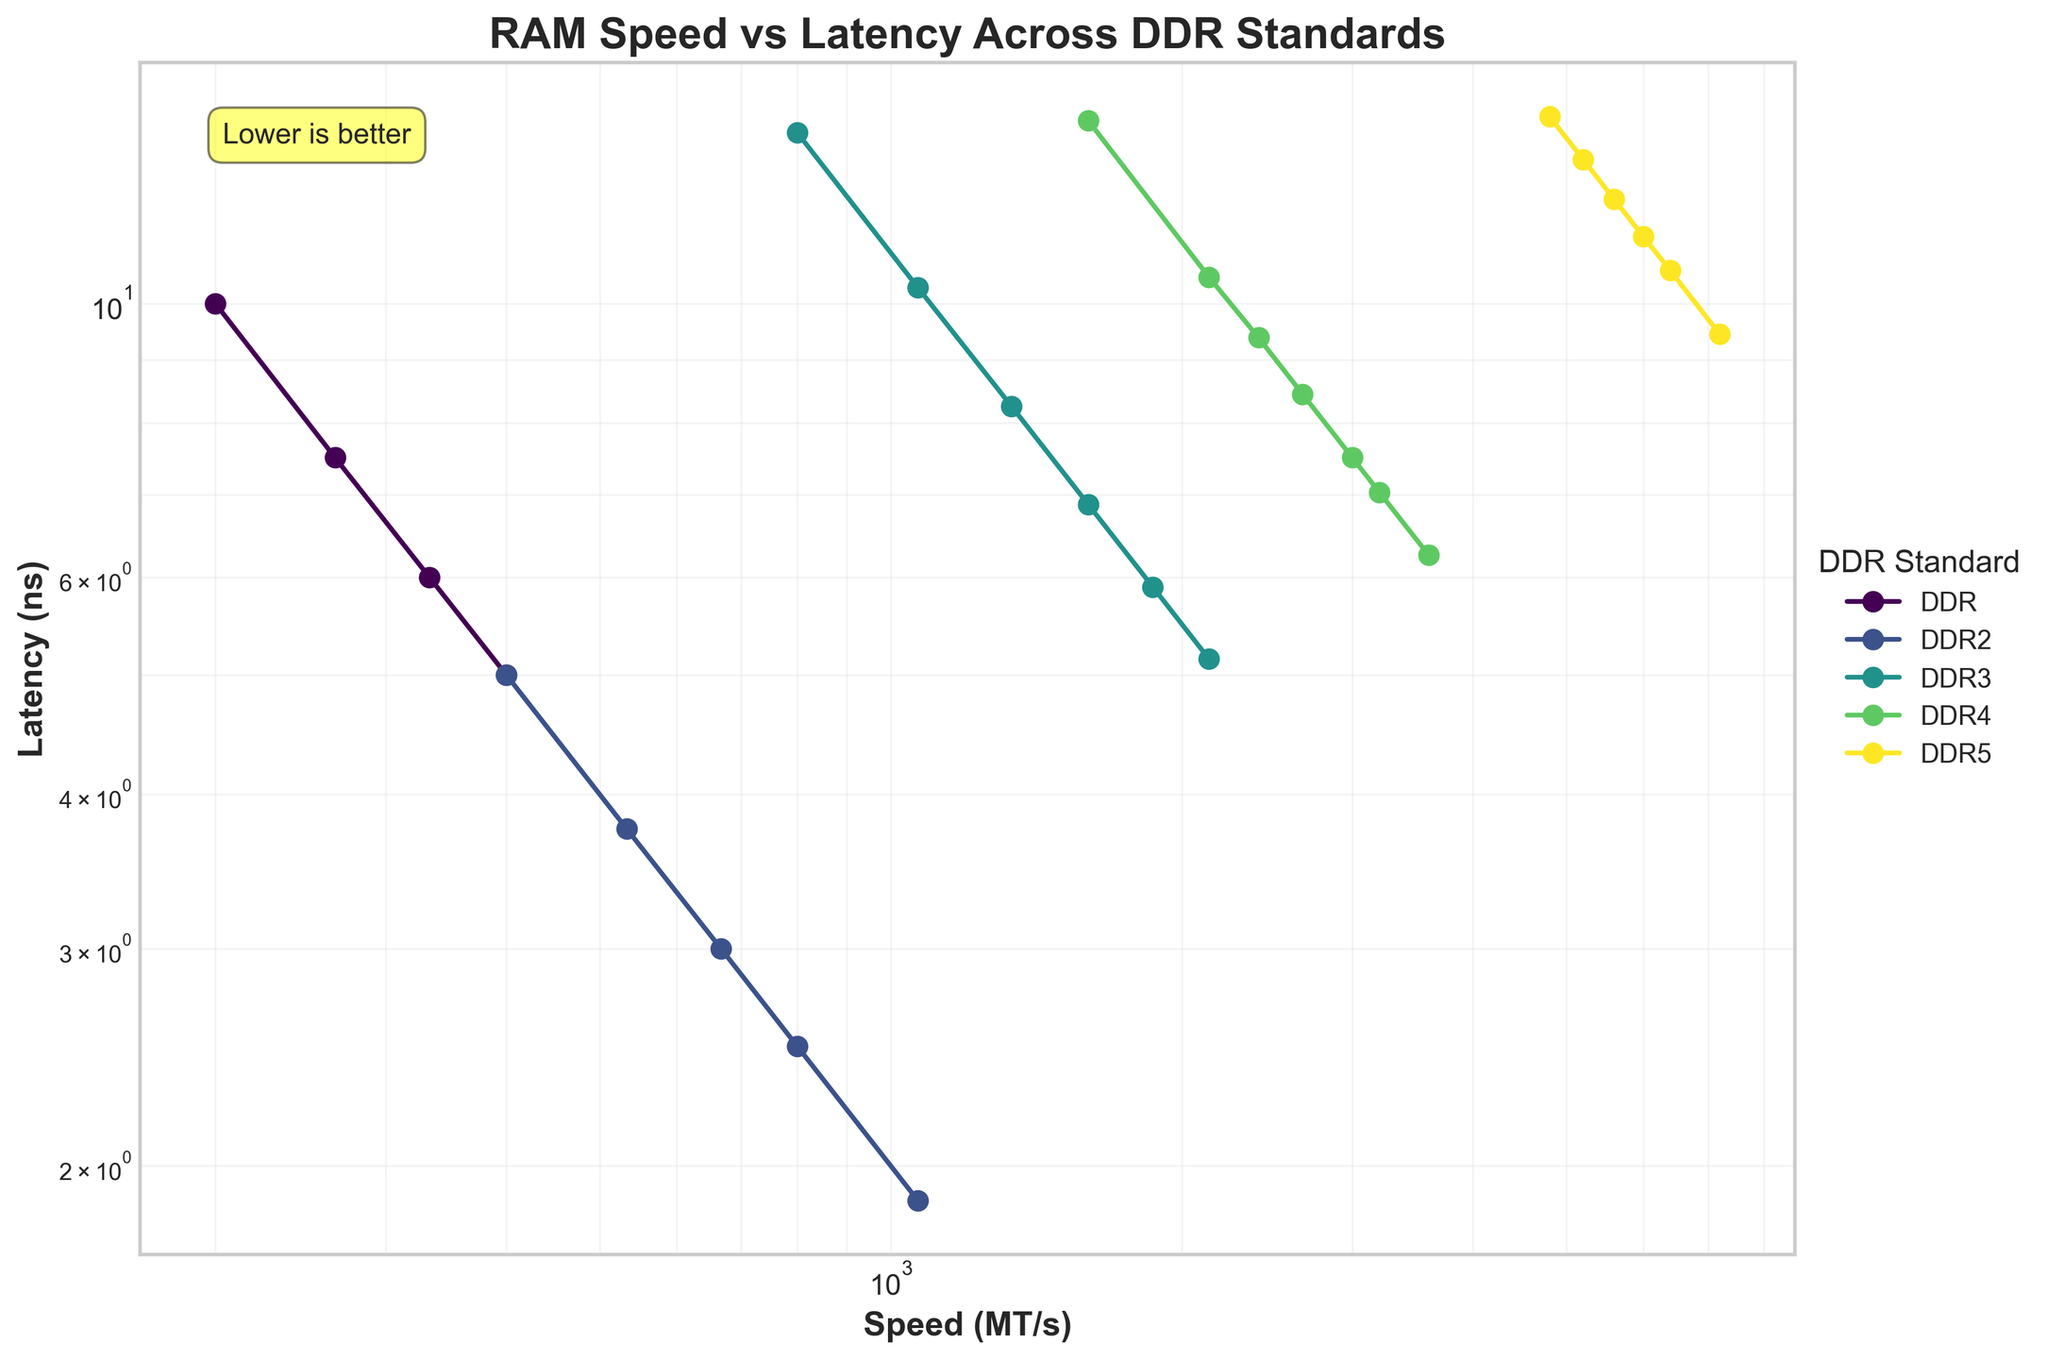What's the DDR standard with the lowest latency for a given speed? To find the DDR standard with the lowest latency for a given speed, look for the lowest point on the y-axis at each specific speed value on the x-axis. For example, at 1600 MT/s, DDR3 has the lowest latency of 6.87 ns.
Answer: DDR3 Which DDR standard has the highest speed with the lowest latency values? To determine which DDR standard has the highest speed and lowest latency, look at the point farthest to the right and lowest on the y-axis in the plot. The DDR5 standard achieves the highest speed of 7200 MT/s with a latency of 9.44 ns.
Answer: DDR5 Compare DDR4 and DDR5 for speed range from 3000 MT/s to 3600 MT/s. Which one has lower latency? For the speed range of 3000 MT/s to 3600 MT/s, find the points within the range for both DDR4 and DDR5, then compare their latencies. DDR4 at 3000 MT/s has 7.5 ns and at 3200 MT/s has 7.03 ns, whereas DDR5 does not have speeds listed precisely within this range. However, DDR4's latencies are generally lower within this specific speed range.
Answer: DDR4 Which DDR standard shows the most apparent decrease in latency as speed increases? To identify which DDR standard shows the most noticeable decrease in latency as speed increases, observe the slopes of the lines. The steepness of the line indicates a significant decrease. DDR2 shows a steep decrease in latency from 5 ns at 400 MT/s to 1.875 ns at 1066 MT/s.
Answer: DDR2 For DDR, what is the difference in latency between 200 MT/s and 400 MT/s? Calculate the difference between the latencies for DDR at 200 MT/s and 400 MT/s. DDR at 200 MT/s has a latency of 10 ns, and at 400 MT/s, it is 5 ns. So, the difference is 10 - 5 = 5 ns.
Answer: 5 ns What is the average latency for DDR4 across all its listed speeds? To find the average latency for DDR4, sum up all the latencies and divide by the number of points. The DDR4 latencies are: 14.06, 10.5, 9.38, 8.44, 7.5, 7.03, 6.25. Their sum is 63.16 ns, and there are 7 points, so average latency is 63.16 / 7 ≈ 9.02 ns.
Answer: 9.02 ns Compare the latencies of DDR3 and DDR4 at the speed of 2133 MT/s. Which one is lower, and by how much? Look at the latencies of both DDR3 and DDR4 at 2133 MT/s. DDR3 at 2133 MT/s has a latency of 5.15 ns, and DDR4 at 2133 MT/s has a latency of 10.5 ns. The difference is 10.5 - 5.15 = 5.35 ns.
Answer: DDR3 by 5.35 ns Which standard exhibits the highest latency, and at what speed? Identify the highest point on the y-axis within the graph. DDR3 at 800 MT/s has the highest latency of 13.75 ns.
Answer: DDR3 at 800 MT/s What trend can be observed for DDR5 latencies as speed increases? Observe the line for DDR5 to detect any trend as speed increases. The plot shows that as speed increases from 4800 MT/s to 7200 MT/s, the latency decreases from 14.17 ns to 9.44 ns, indicating a downward trend.
Answer: Latency decreases as speed increases What's the rate of latency reduction for DDR2 from 400 MT/s to 1066 MT/s? Calculate the rate by finding the difference in latency at the given speeds and dividing by the difference in those speeds. Latency at 400 MT/s is 5 ns and at 1066 MT/s is 1.875 ns. Difference in latency is 5 - 1.875 = 3.125 ns, and difference in speed is 1066 - 400 = 666 MT/s. The rate is 3.125 / 666 ≈ 0.0047 ns/MT/s.
Answer: 0.0047 ns/MT/s 